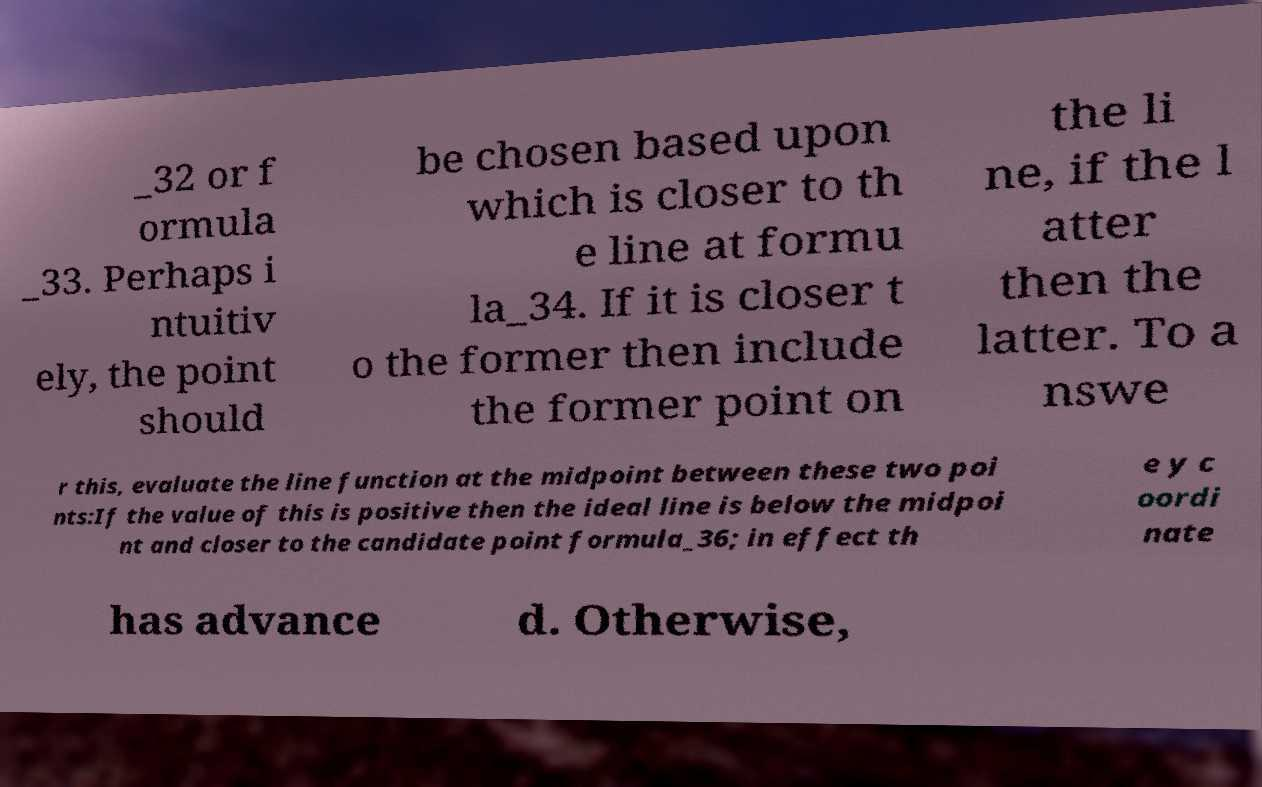Please identify and transcribe the text found in this image. _32 or f ormula _33. Perhaps i ntuitiv ely, the point should be chosen based upon which is closer to th e line at formu la_34. If it is closer t o the former then include the former point on the li ne, if the l atter then the latter. To a nswe r this, evaluate the line function at the midpoint between these two poi nts:If the value of this is positive then the ideal line is below the midpoi nt and closer to the candidate point formula_36; in effect th e y c oordi nate has advance d. Otherwise, 